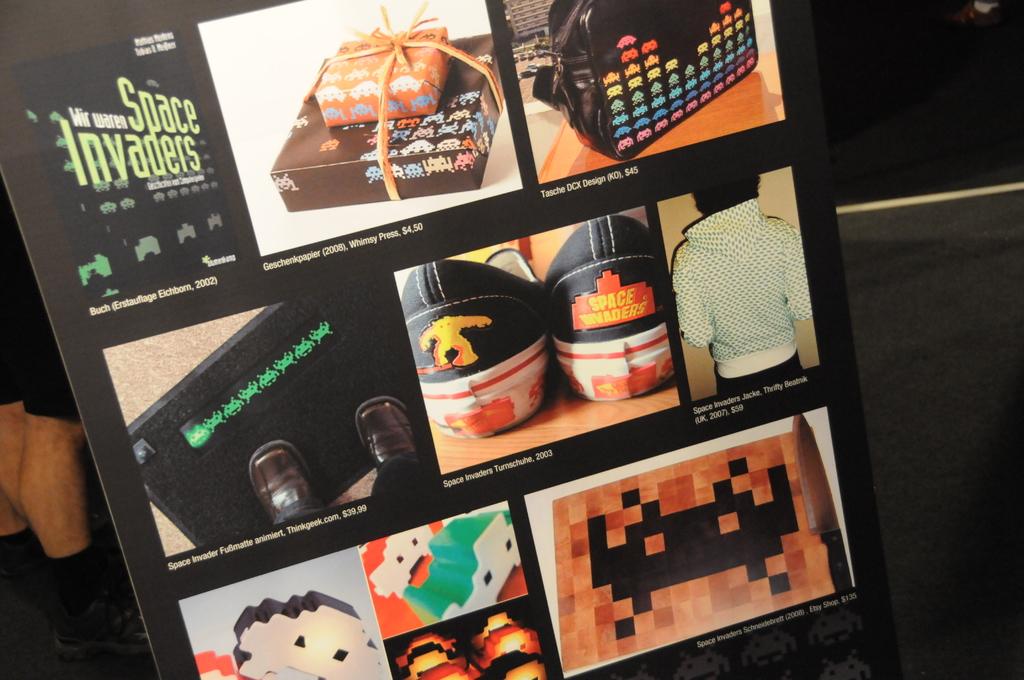What game name is on the top left of the board?
Offer a terse response. Space invaders. 